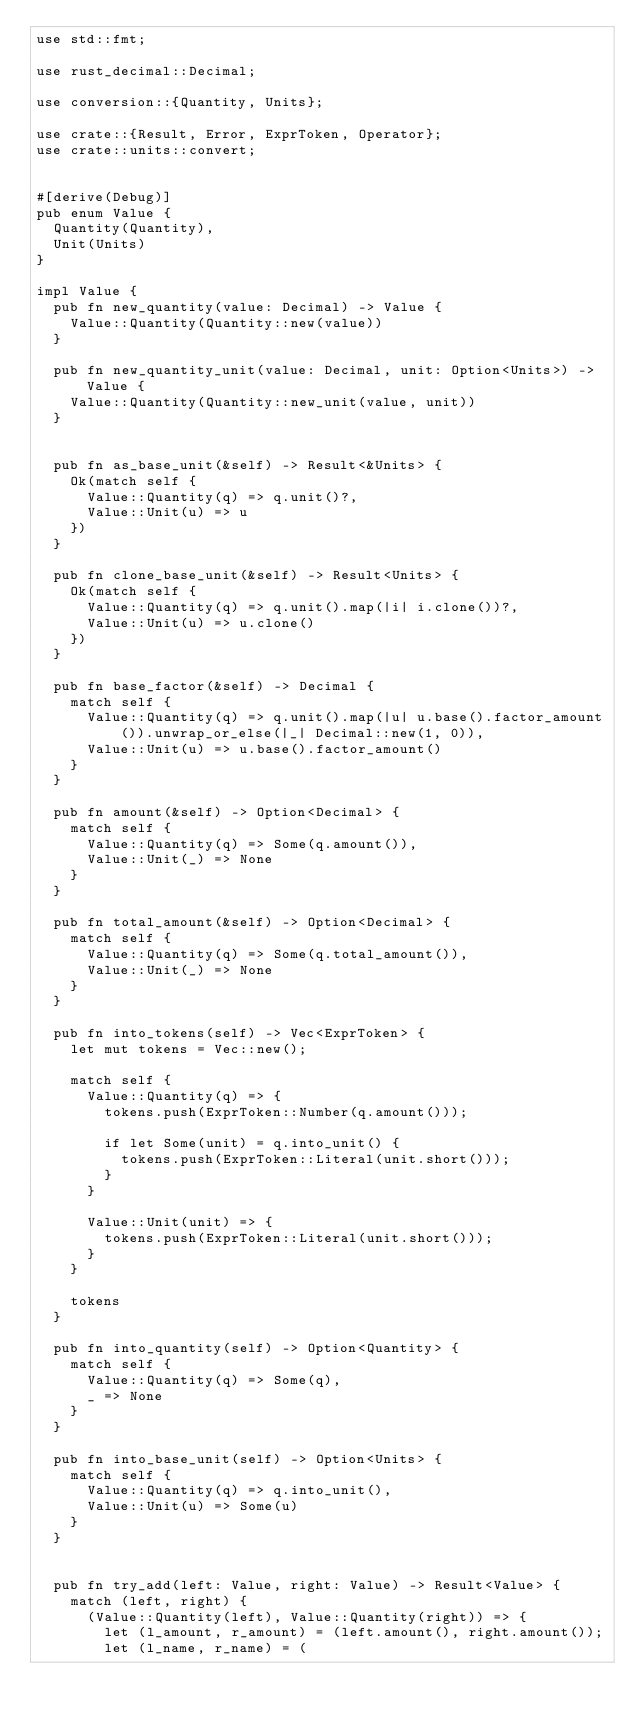Convert code to text. <code><loc_0><loc_0><loc_500><loc_500><_Rust_>use std::fmt;

use rust_decimal::Decimal;

use conversion::{Quantity, Units};

use crate::{Result, Error, ExprToken, Operator};
use crate::units::convert;


#[derive(Debug)]
pub enum Value {
	Quantity(Quantity),
	Unit(Units)
}

impl Value {
	pub fn new_quantity(value: Decimal) -> Value {
		Value::Quantity(Quantity::new(value))
	}

	pub fn new_quantity_unit(value: Decimal, unit: Option<Units>) -> Value {
		Value::Quantity(Quantity::new_unit(value, unit))
	}


	pub fn as_base_unit(&self) -> Result<&Units> {
		Ok(match self {
			Value::Quantity(q) => q.unit()?,
			Value::Unit(u) => u
		})
	}

	pub fn clone_base_unit(&self) -> Result<Units> {
		Ok(match self {
			Value::Quantity(q) => q.unit().map(|i| i.clone())?,
			Value::Unit(u) => u.clone()
		})
	}

	pub fn base_factor(&self) -> Decimal {
		match self {
			Value::Quantity(q) => q.unit().map(|u| u.base().factor_amount()).unwrap_or_else(|_| Decimal::new(1, 0)),
			Value::Unit(u) => u.base().factor_amount()
		}
	}

	pub fn amount(&self) -> Option<Decimal> {
		match self {
			Value::Quantity(q) => Some(q.amount()),
			Value::Unit(_) => None
		}
	}

	pub fn total_amount(&self) -> Option<Decimal> {
		match self {
			Value::Quantity(q) => Some(q.total_amount()),
			Value::Unit(_) => None
		}
	}

	pub fn into_tokens(self) -> Vec<ExprToken> {
		let mut tokens = Vec::new();

		match self {
			Value::Quantity(q) => {
				tokens.push(ExprToken::Number(q.amount()));

				if let Some(unit) = q.into_unit() {
					tokens.push(ExprToken::Literal(unit.short()));
				}
			}

			Value::Unit(unit) => {
				tokens.push(ExprToken::Literal(unit.short()));
			}
		}

		tokens
	}

	pub fn into_quantity(self) -> Option<Quantity> {
		match self {
			Value::Quantity(q) => Some(q),
			_ => None
		}
	}

	pub fn into_base_unit(self) -> Option<Units> {
		match self {
			Value::Quantity(q) => q.into_unit(),
			Value::Unit(u) => Some(u)
		}
	}


	pub fn try_add(left: Value, right: Value) -> Result<Value> {
		match (left, right) {
			(Value::Quantity(left), Value::Quantity(right)) => {
				let (l_amount, r_amount) = (left.amount(), right.amount());
				let (l_name, r_name) = (</code> 